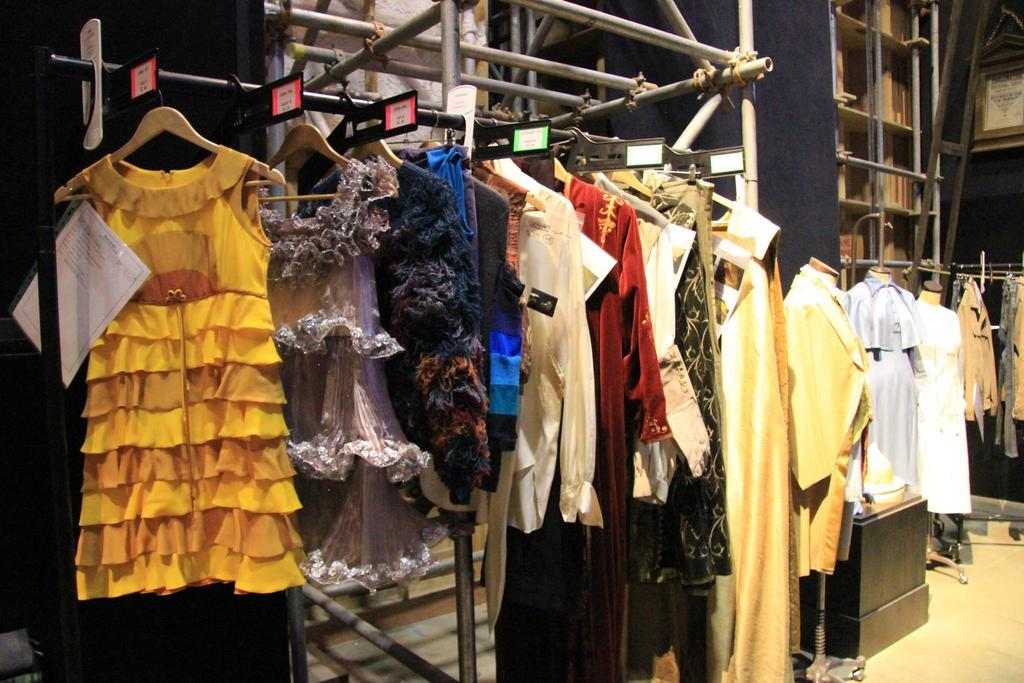What type of clothing items can be seen in the image? There are dresses in the image. Where might this image have been taken? The image appears to be from a store. How are the dresses displayed in the image? There are hangers in the image, which are likely used to display the dresses. Are there any figures wearing the dresses in the image? Yes, there are mannequins in the image, which are likely wearing the dresses. What type of leather goods can be seen on the mannequins in the image? There is no leather goods visible on the mannequins in the image; they are wearing dresses. What kind of offer is being made for the dresses in the image? There is no information about any offer for the dresses in the image; it only shows the dresses on display. 